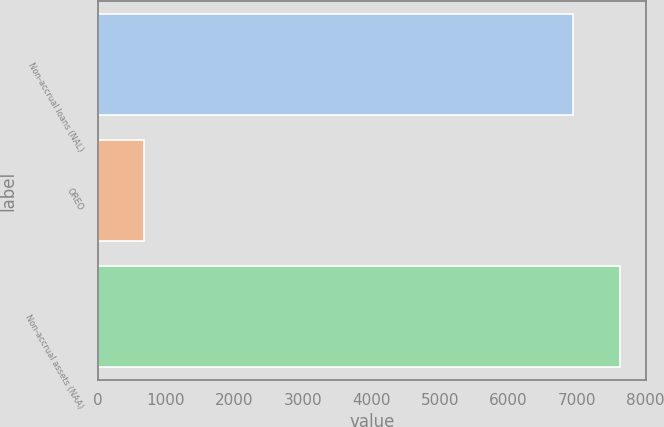<chart> <loc_0><loc_0><loc_500><loc_500><bar_chart><fcel>Non-accrual loans (NAL)<fcel>OREO<fcel>Non-accrual assets (NAA)<nl><fcel>6941<fcel>679<fcel>7635.1<nl></chart> 